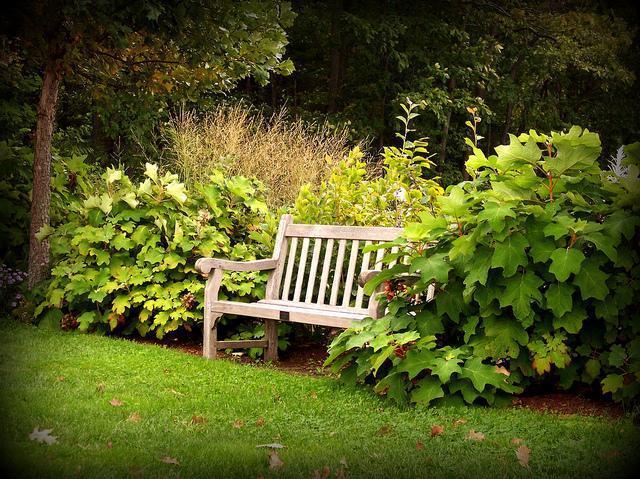How many people can sit on the bench at once?
Give a very brief answer. 3. 